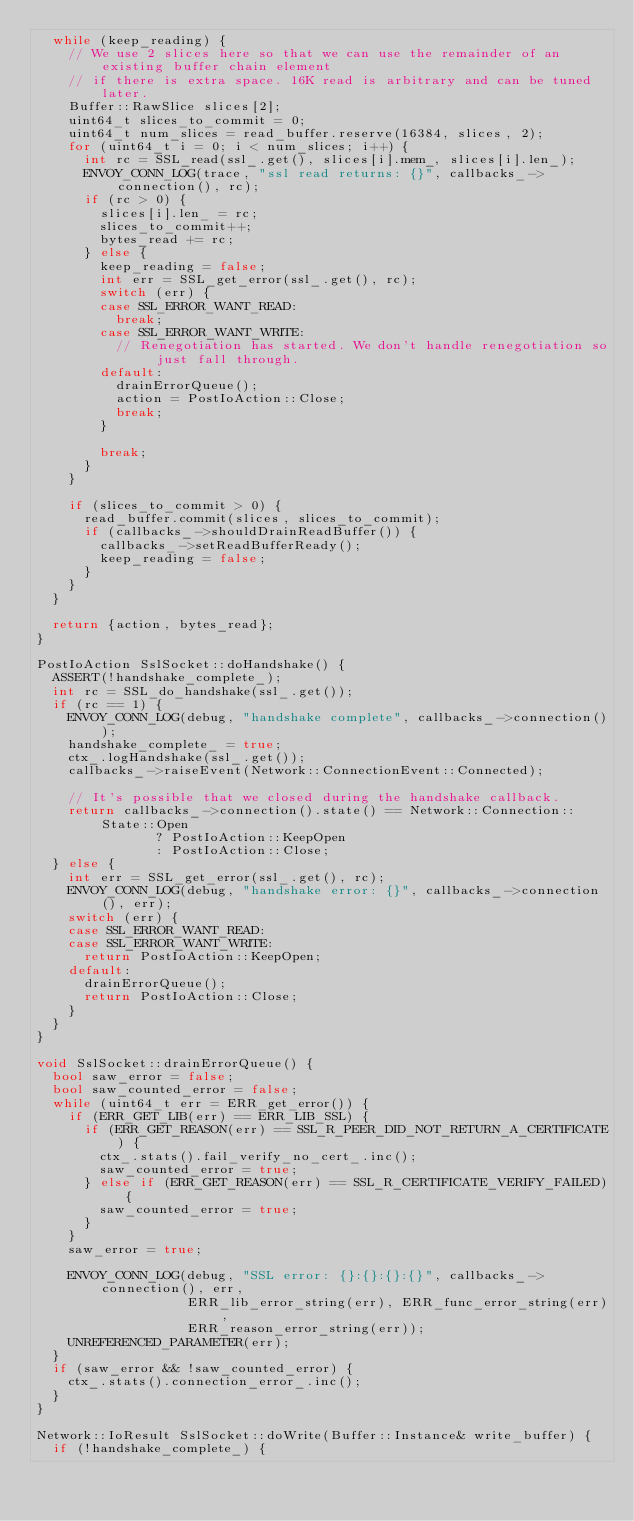Convert code to text. <code><loc_0><loc_0><loc_500><loc_500><_C++_>  while (keep_reading) {
    // We use 2 slices here so that we can use the remainder of an existing buffer chain element
    // if there is extra space. 16K read is arbitrary and can be tuned later.
    Buffer::RawSlice slices[2];
    uint64_t slices_to_commit = 0;
    uint64_t num_slices = read_buffer.reserve(16384, slices, 2);
    for (uint64_t i = 0; i < num_slices; i++) {
      int rc = SSL_read(ssl_.get(), slices[i].mem_, slices[i].len_);
      ENVOY_CONN_LOG(trace, "ssl read returns: {}", callbacks_->connection(), rc);
      if (rc > 0) {
        slices[i].len_ = rc;
        slices_to_commit++;
        bytes_read += rc;
      } else {
        keep_reading = false;
        int err = SSL_get_error(ssl_.get(), rc);
        switch (err) {
        case SSL_ERROR_WANT_READ:
          break;
        case SSL_ERROR_WANT_WRITE:
          // Renegotiation has started. We don't handle renegotiation so just fall through.
        default:
          drainErrorQueue();
          action = PostIoAction::Close;
          break;
        }

        break;
      }
    }

    if (slices_to_commit > 0) {
      read_buffer.commit(slices, slices_to_commit);
      if (callbacks_->shouldDrainReadBuffer()) {
        callbacks_->setReadBufferReady();
        keep_reading = false;
      }
    }
  }

  return {action, bytes_read};
}

PostIoAction SslSocket::doHandshake() {
  ASSERT(!handshake_complete_);
  int rc = SSL_do_handshake(ssl_.get());
  if (rc == 1) {
    ENVOY_CONN_LOG(debug, "handshake complete", callbacks_->connection());
    handshake_complete_ = true;
    ctx_.logHandshake(ssl_.get());
    callbacks_->raiseEvent(Network::ConnectionEvent::Connected);

    // It's possible that we closed during the handshake callback.
    return callbacks_->connection().state() == Network::Connection::State::Open
               ? PostIoAction::KeepOpen
               : PostIoAction::Close;
  } else {
    int err = SSL_get_error(ssl_.get(), rc);
    ENVOY_CONN_LOG(debug, "handshake error: {}", callbacks_->connection(), err);
    switch (err) {
    case SSL_ERROR_WANT_READ:
    case SSL_ERROR_WANT_WRITE:
      return PostIoAction::KeepOpen;
    default:
      drainErrorQueue();
      return PostIoAction::Close;
    }
  }
}

void SslSocket::drainErrorQueue() {
  bool saw_error = false;
  bool saw_counted_error = false;
  while (uint64_t err = ERR_get_error()) {
    if (ERR_GET_LIB(err) == ERR_LIB_SSL) {
      if (ERR_GET_REASON(err) == SSL_R_PEER_DID_NOT_RETURN_A_CERTIFICATE) {
        ctx_.stats().fail_verify_no_cert_.inc();
        saw_counted_error = true;
      } else if (ERR_GET_REASON(err) == SSL_R_CERTIFICATE_VERIFY_FAILED) {
        saw_counted_error = true;
      }
    }
    saw_error = true;

    ENVOY_CONN_LOG(debug, "SSL error: {}:{}:{}:{}", callbacks_->connection(), err,
                   ERR_lib_error_string(err), ERR_func_error_string(err),
                   ERR_reason_error_string(err));
    UNREFERENCED_PARAMETER(err);
  }
  if (saw_error && !saw_counted_error) {
    ctx_.stats().connection_error_.inc();
  }
}

Network::IoResult SslSocket::doWrite(Buffer::Instance& write_buffer) {
  if (!handshake_complete_) {</code> 